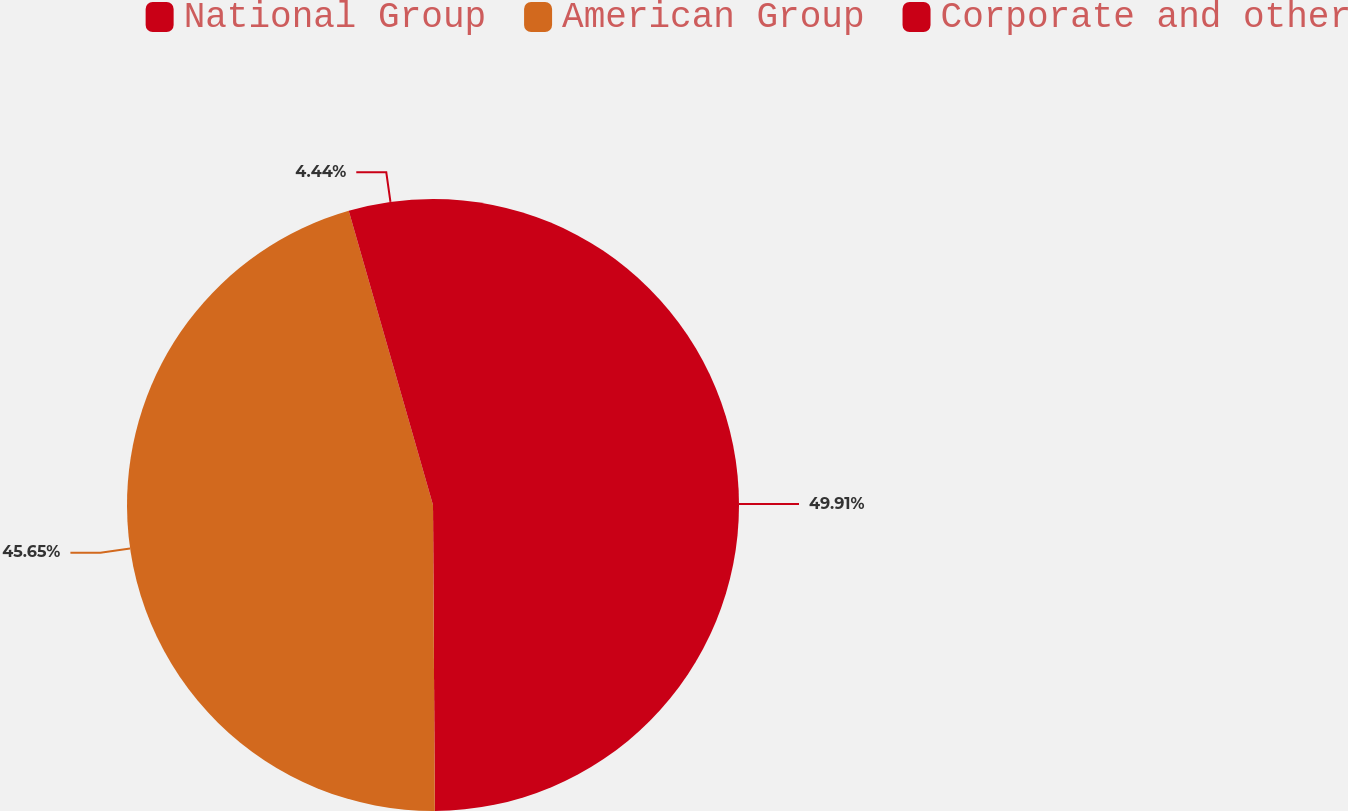<chart> <loc_0><loc_0><loc_500><loc_500><pie_chart><fcel>National Group<fcel>American Group<fcel>Corporate and other<nl><fcel>49.9%<fcel>45.65%<fcel>4.44%<nl></chart> 